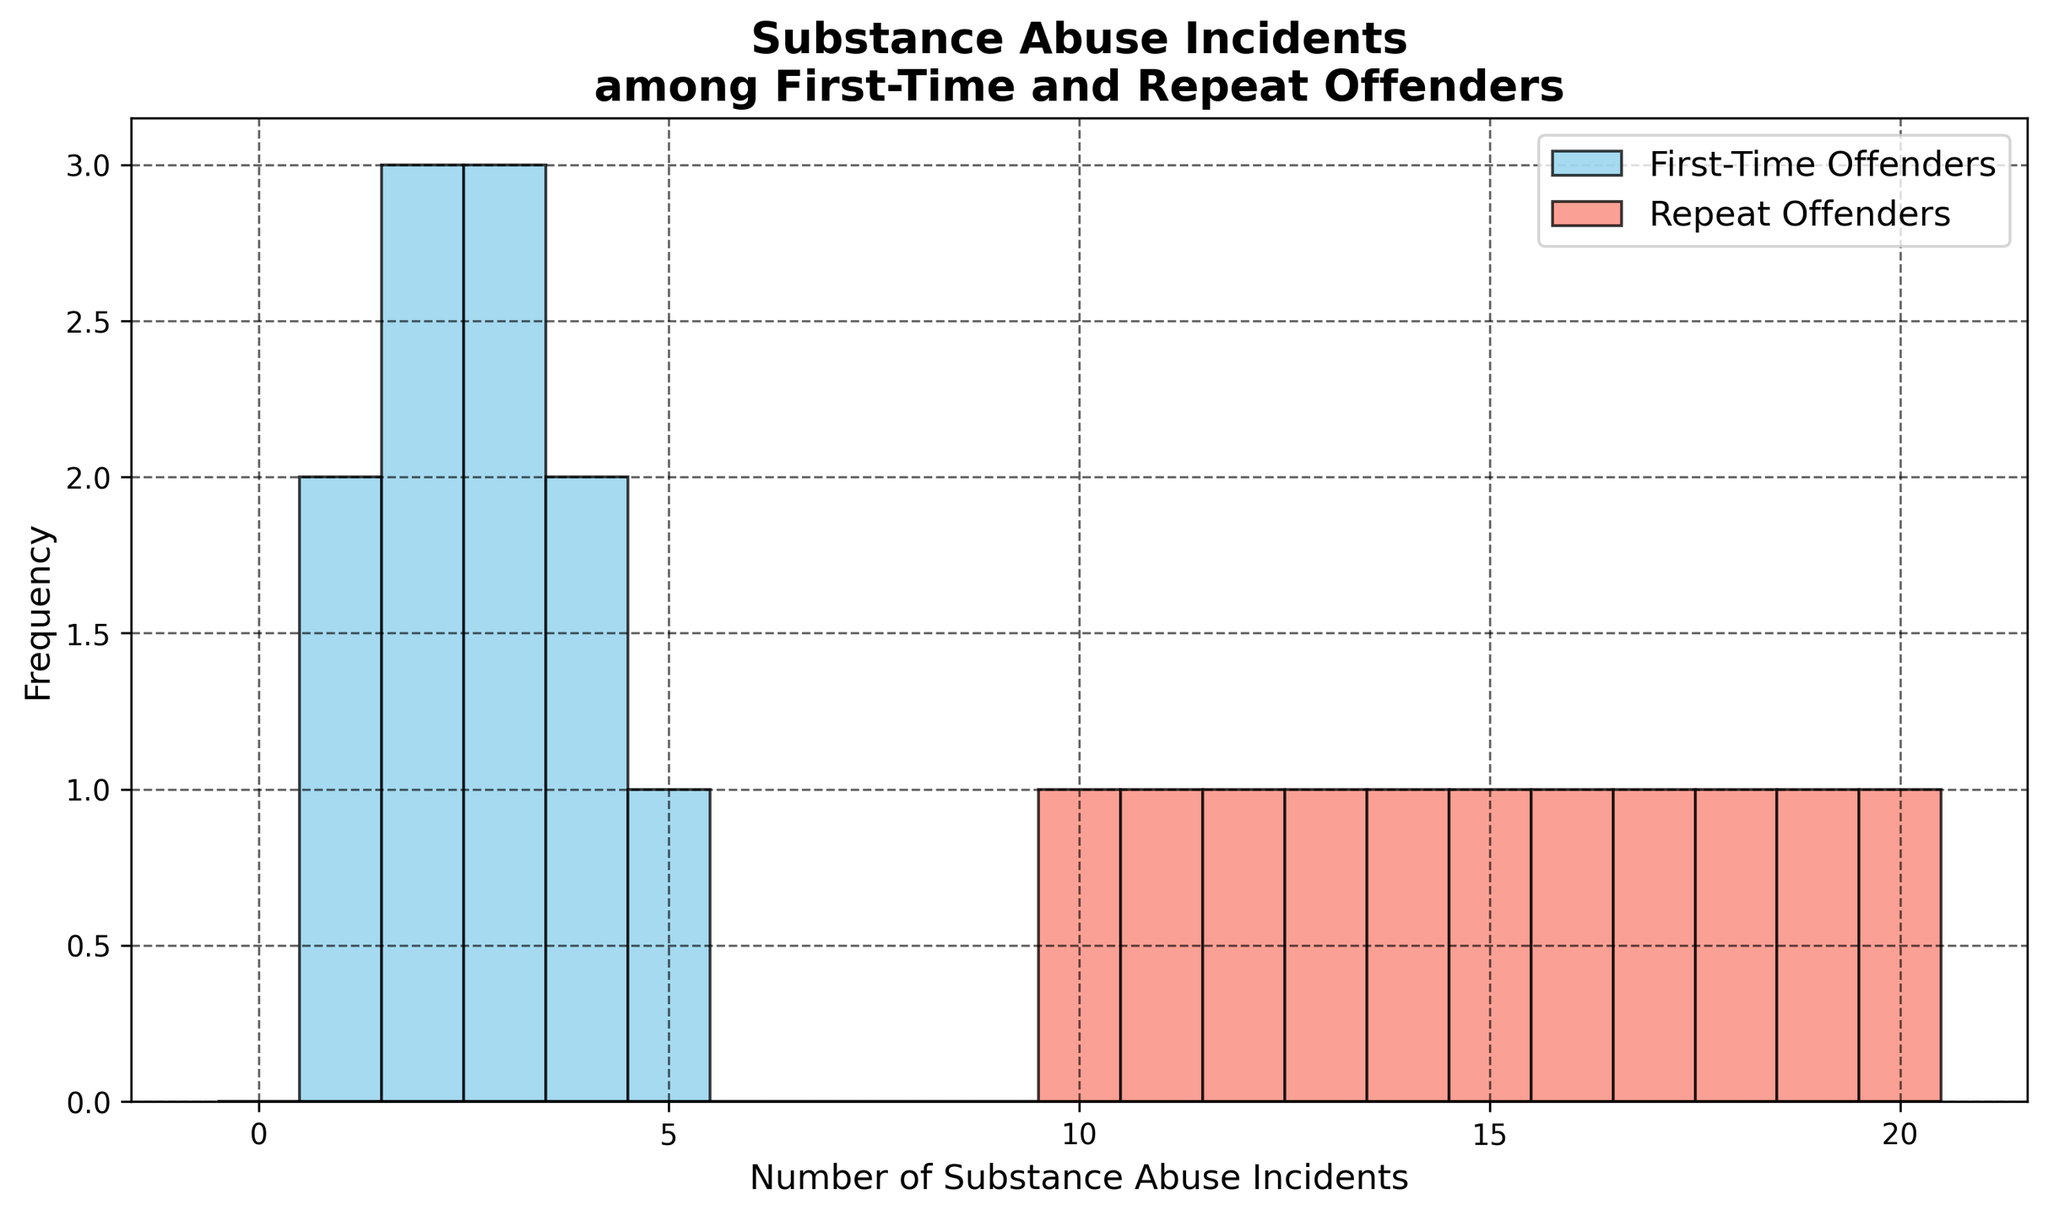What is the most frequently reported number of substance abuse incidents among repeat offenders? The tallest bar in the histogram for repeat offenders indicates the most common number of substance abuse incidents.
Answer: 19 What is the combined number of incidents for first-time offenders reporting 2 or fewer incidents? Sum the frequencies for 2 incidents and fewer: 2 incidents (3 times) and 1 incident (2 times), giving 3 + 2 = 5.
Answer: 5 Which group has a larger spread of substance abuse incidents? By observing the extent of the histogram bars along the x-axis for each group, repeat offenders cover a wider range (1-20) compared to first-time offenders (1-5).
Answer: Repeat offenders How many times does the number of substance abuse incidents equal exactly 3 for first-time offenders? Simply count the frequency of the bar corresponding to 3 incidents for first-time offenders.
Answer: 2 What is the difference in the maximum number of incidents between first-time offenders and repeat offenders? The maximum value for first-time offenders is 5, and for repeat offenders it is 20. The difference is 20 - 5 = 15.
Answer: 15 How many more repeat offenders report 15 incidents compared to first-time offenders reporting 4 incidents? Count each bar: 15 incidents for repeat offenders occurs once and 4 incidents for first-time offenders occurs twice. The difference is 1 - 2 = -1.
Answer: -1 (2 fewer) Which color represents first-time offenders in the histogram? By checking the color of the bars in the legend, first-time offenders are represented by sky blue.
Answer: Sky blue Can you identify the modal (most common) number of incidents for first-time offenders and compare it to the modal number for repeat offenders? The modal number of incidents for first-time offenders is the highest bar count (2 incidents, 3 times) and for repeat offenders is 19 incidents (the highest bar count).
Answer: First-time: 2, Repeat: 19 Considering incidents of 4 or more, how many incidents are reported overall within each offender category? Sum the frequencies for bars representing 4 or greater for each group. First-time (only 4 and 5): 1 (4 incidents) + 1 (5 incidents) = 2. Repeat (from 10 to 20): 10 + 15 + 12 + 18 + 17 + 19 + 20 + 11 + 16 + 14 + 13.
Answer: First-time: 2, Repeat: 145 Observing the histogram, how would you describe the trend in the number of substance abuse incidents as it relates to offender type? First-time offenders show fewer incidents with values mostly clustered between 1 and 5. Repeat offenders show a broader distribution with higher frequency counts.
Answer: First-time: Low incidents, clustered; Repeat: Wide distribution, higher frequency 